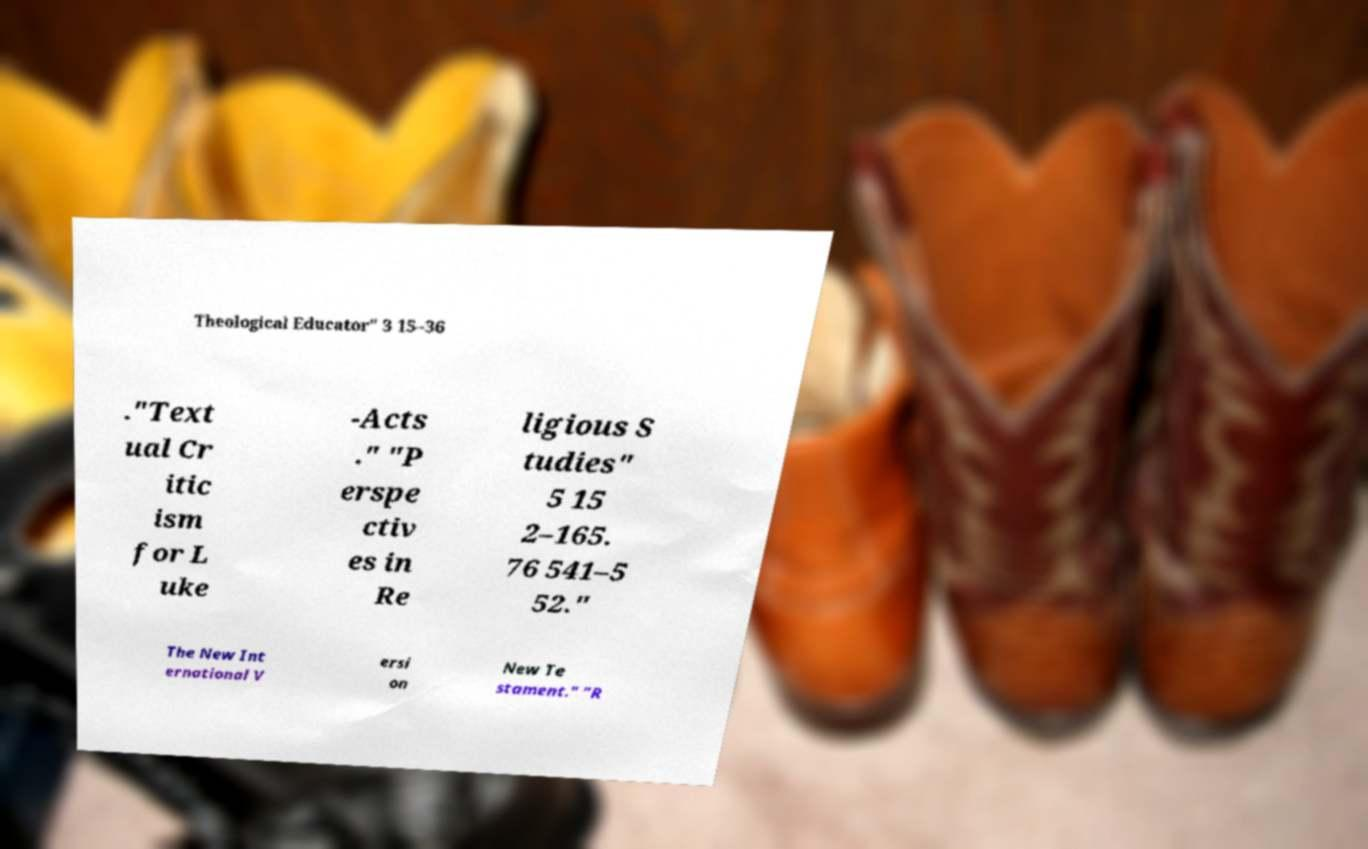Can you read and provide the text displayed in the image?This photo seems to have some interesting text. Can you extract and type it out for me? Theological Educator" 3 15–36 ."Text ual Cr itic ism for L uke -Acts ." "P erspe ctiv es in Re ligious S tudies" 5 15 2–165. 76 541–5 52." The New Int ernational V ersi on New Te stament." "R 